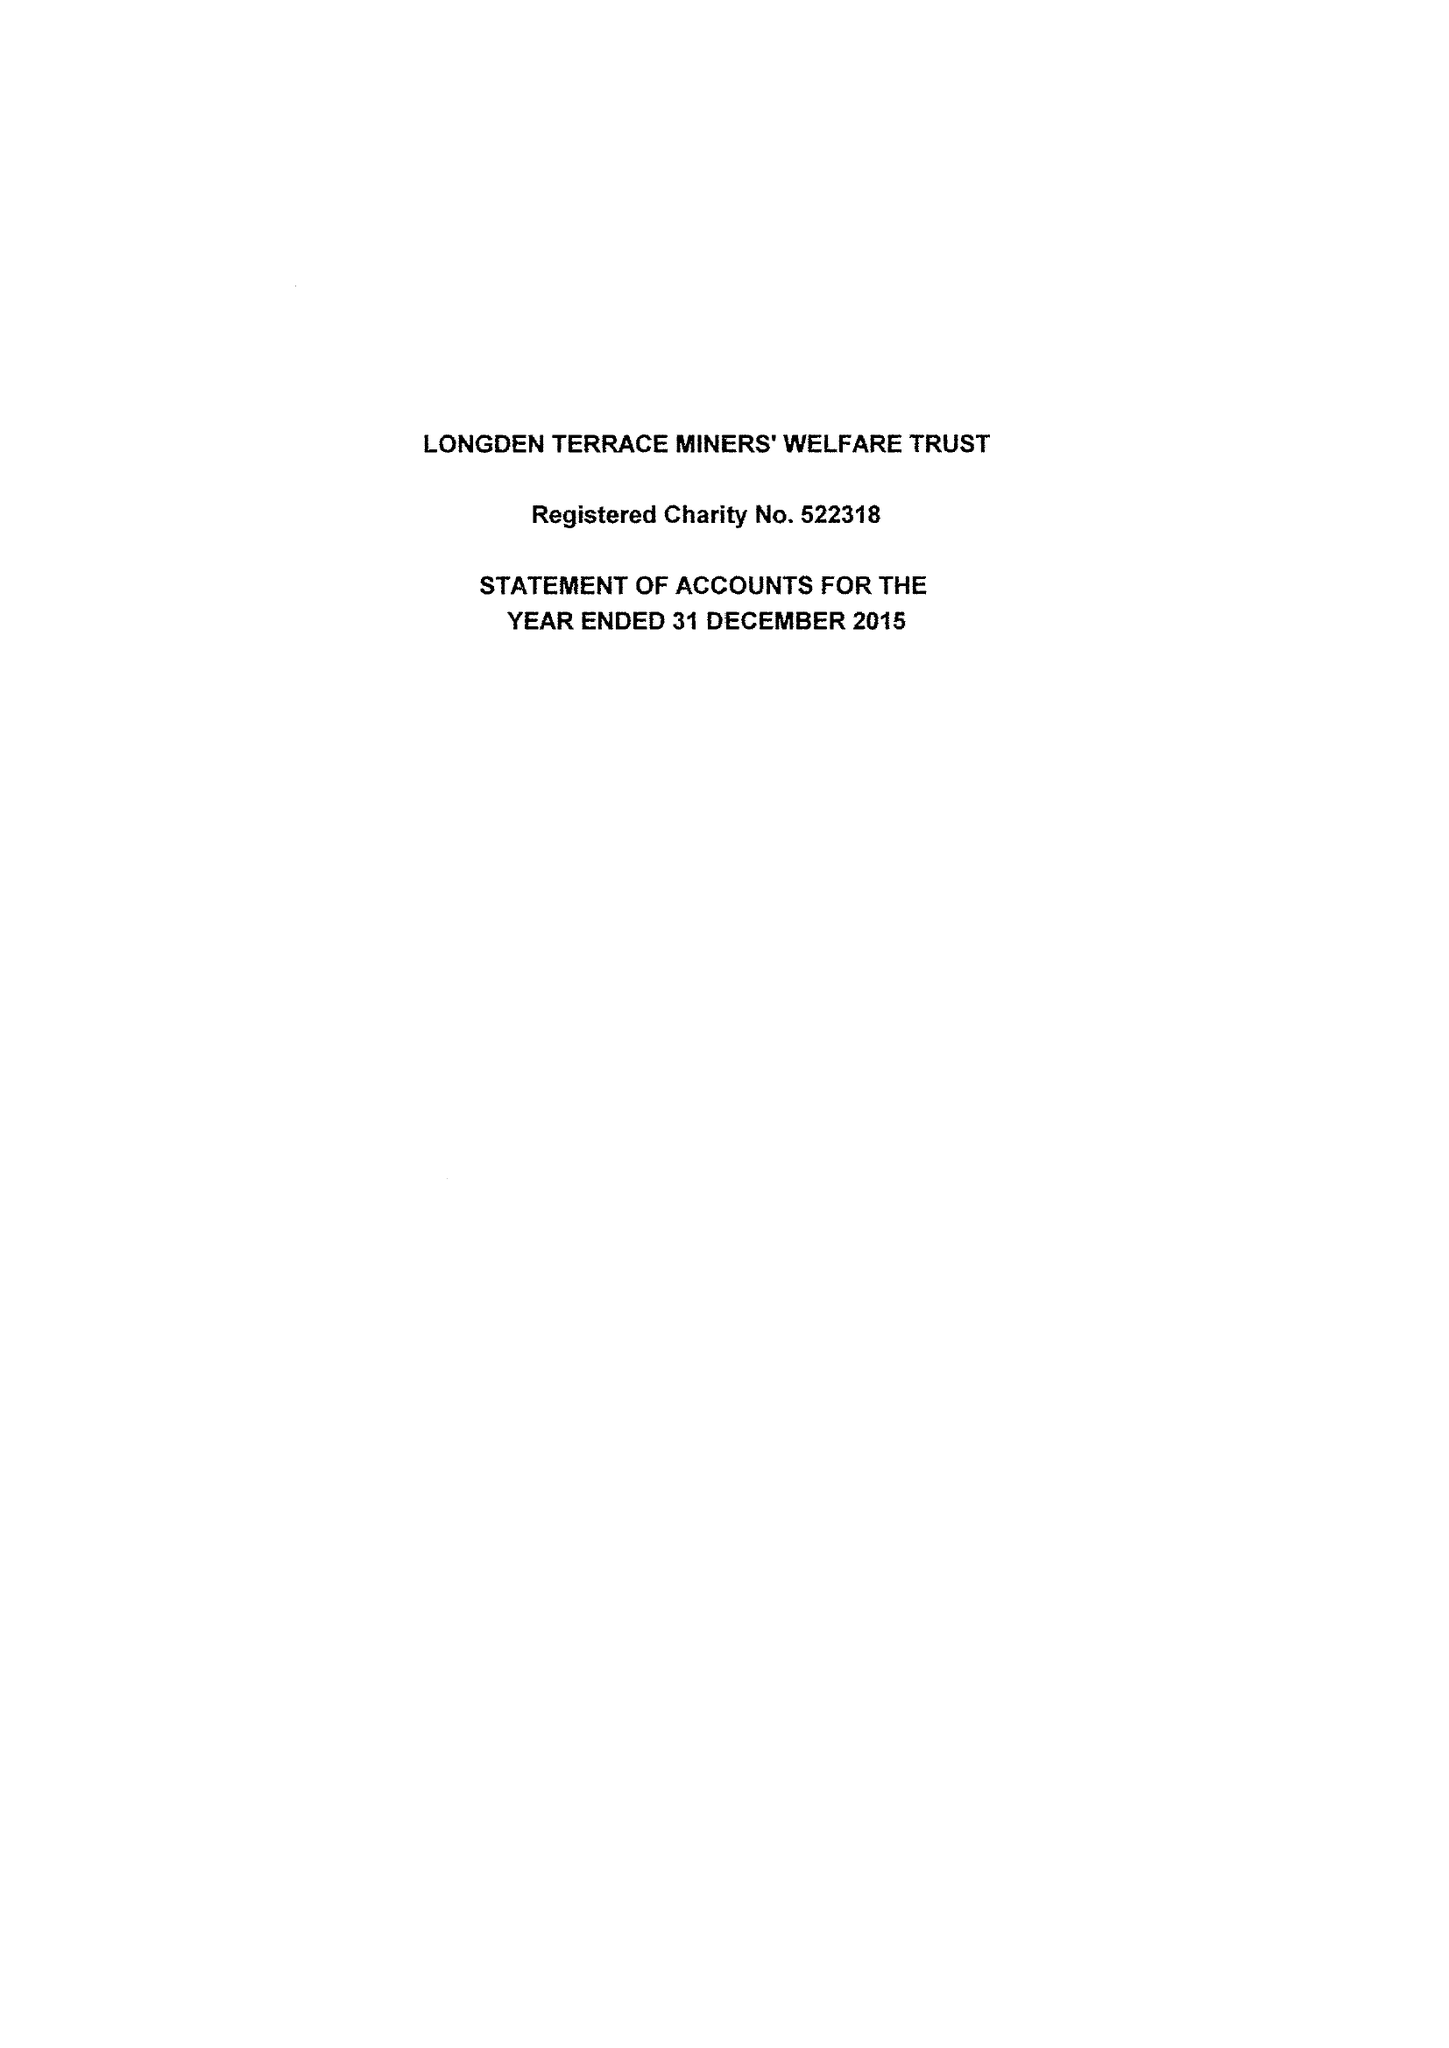What is the value for the income_annually_in_british_pounds?
Answer the question using a single word or phrase. 39342.00 